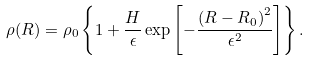<formula> <loc_0><loc_0><loc_500><loc_500>\rho ( R ) = \rho _ { 0 } \left \{ 1 + \frac { H } { \epsilon } \exp \left [ - \frac { \left ( R - R _ { 0 } \right ) ^ { 2 } } { \epsilon ^ { 2 } } \right ] \right \} .</formula> 